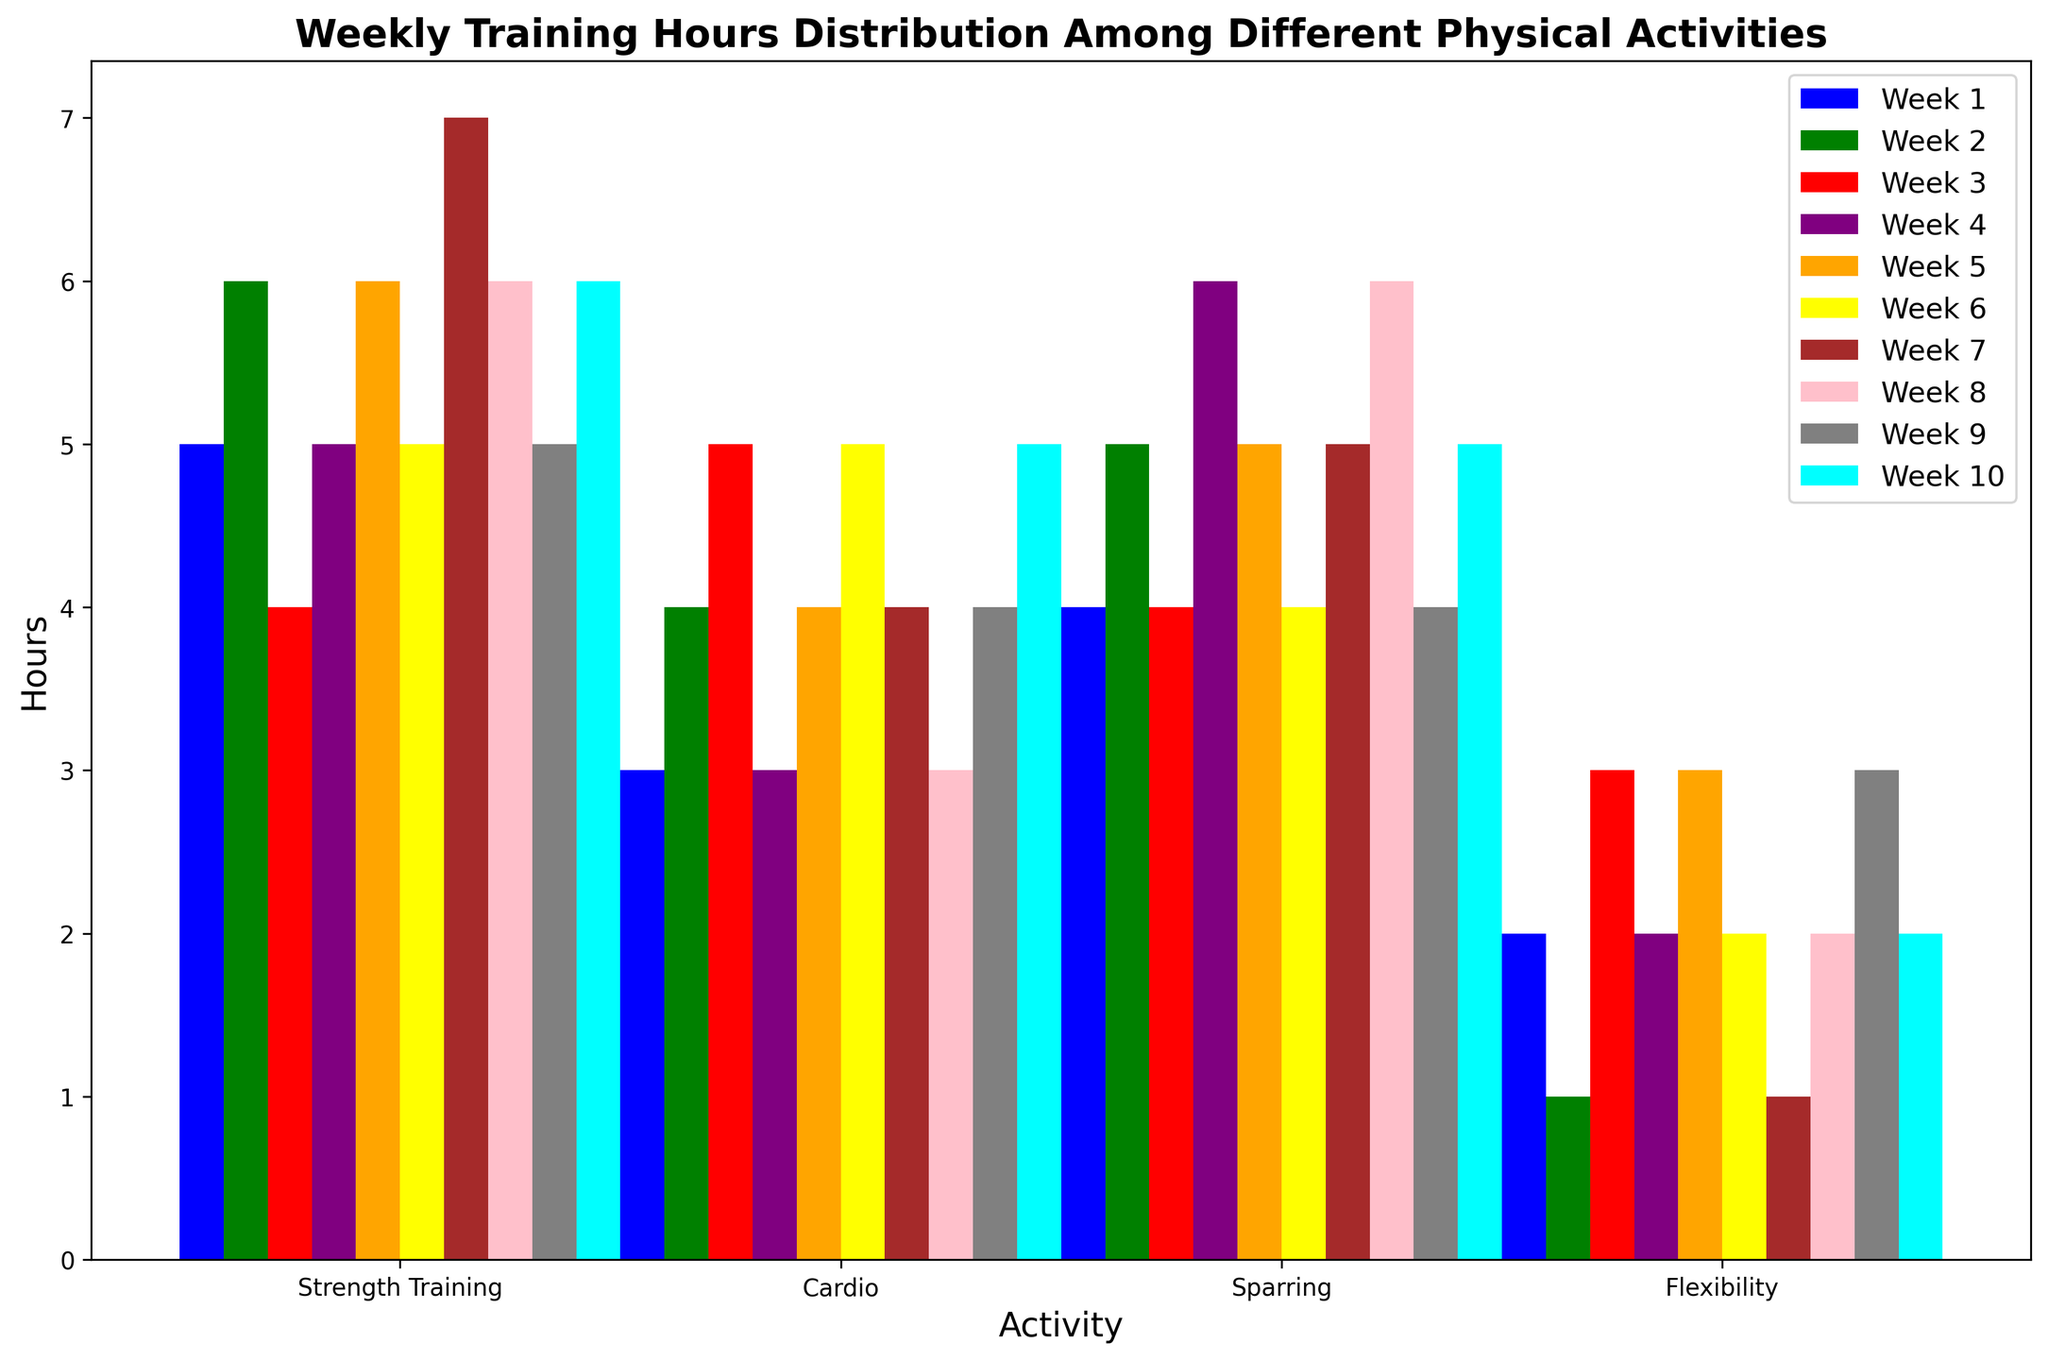What is the average time spent on Strength Training across all weeks? We need to add up the number of hours spent on Strength Training for all 10 weeks and then divide by 10. The values are [5, 6, 4, 5, 6, 5, 7, 6, 5, 6]. The sum is 55 and the average is 55/10.
Answer: 5.5 Which activity had the most consistency in hours spent weekly? To determine consistency, we look at the variance in hours spent across the weeks for each activity. Flexibility shows the least variability with values [2, 1, 3, 2, 3, 2, 1, 2, 3, 2].
Answer: Flexibility What is the total number of hours spent on Sparring in Week 4? Referred to Week 4 column, look at Sparring hours.
Answer: 6 Which week had the least amount of Cardio training? Compare Cardio training hours across all weeks and identify the minimum. The hours for Cardio are [3, 4, 5, 3, 4, 5, 4, 3, 4, 5]. The lowest is 3.
Answer: Week 1, Week 4, Week 8 Which activity shows the highest increase in hours from the first week to the last week? We check the difference in hours between Week 1 and Week 10 for each activity. For Flexibility, the hours change from 2 to 2 (0 increase). For Strength Training, they change from 5 to 6 (+1). For Cardio, they change from 3 to 5 (+2). For Sparring, they change from 4 to 5 (+1). Cardio shows the highest increase.
Answer: Cardio Which activity had the most hours in Week 7? Examine Week 7 data. The values are [Strength Training: 7, Cardio: 4, Sparring: 5, Flexibility: 1]. Strength Training is highest.
Answer: Strength Training What is the total number of hours spent on all activities in Week 5? Sum the hours for all activities in Week 5. The values are [6, 4, 5, 3], so the sum is 18.
Answer: 18 In Week 3, how many more hours were spent on Cardio than on Flexibility? The hours for Week 3 are Cardio: 5, Flexibility: 3. The difference is 5 - 3.
Answer: 2 Which two weeks had the closest total training hours across all activities? Calculate the total hours for each week, compare differences: [14, 16, 16, 16, 18, 16, 17, 17, 16, 18]. Weeks 3, 4, 6, and 9 (all with 16 hours) are the closest.
Answer: Weeks 3, 4, 6, and 9 What percentage of the total training hours in Week 2 was spent on Strength Training? Sum the hours of all activities in Week 2 ([6, 4, 5, 1] = 16). Strength Training is 6. Percentage = (6 / 16) * 100 ≈ 37.5%.
Answer: 37.5% 